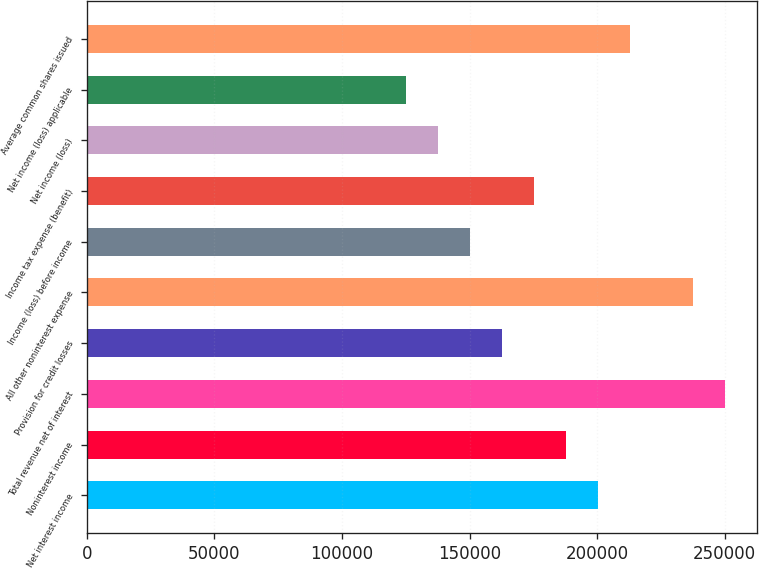<chart> <loc_0><loc_0><loc_500><loc_500><bar_chart><fcel>Net interest income<fcel>Noninterest income<fcel>Total revenue net of interest<fcel>Provision for credit losses<fcel>All other noninterest expense<fcel>Income (loss) before income<fcel>Income tax expense (benefit)<fcel>Net income (loss)<fcel>Net income (loss) applicable<fcel>Average common shares issued<nl><fcel>200218<fcel>187704<fcel>250272<fcel>162677<fcel>237758<fcel>150163<fcel>175190<fcel>137650<fcel>125136<fcel>212731<nl></chart> 